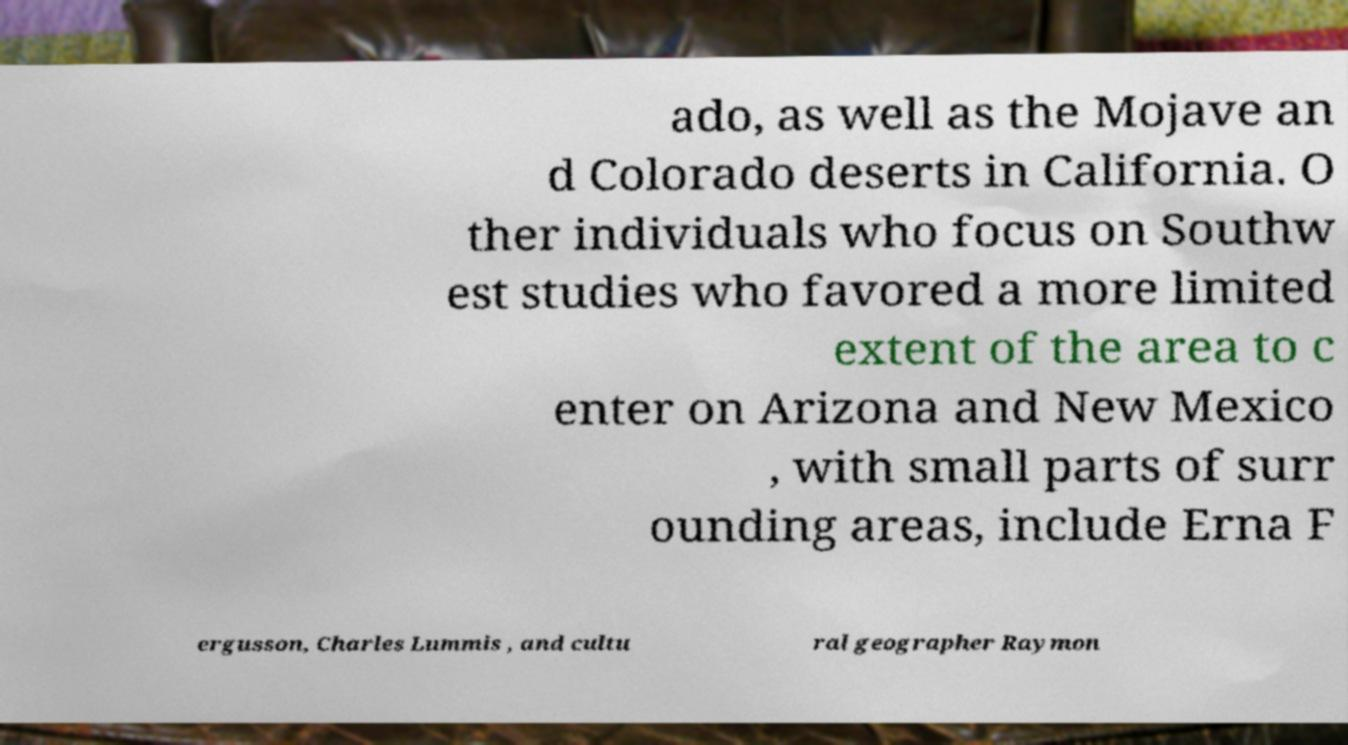I need the written content from this picture converted into text. Can you do that? ado, as well as the Mojave an d Colorado deserts in California. O ther individuals who focus on Southw est studies who favored a more limited extent of the area to c enter on Arizona and New Mexico , with small parts of surr ounding areas, include Erna F ergusson, Charles Lummis , and cultu ral geographer Raymon 